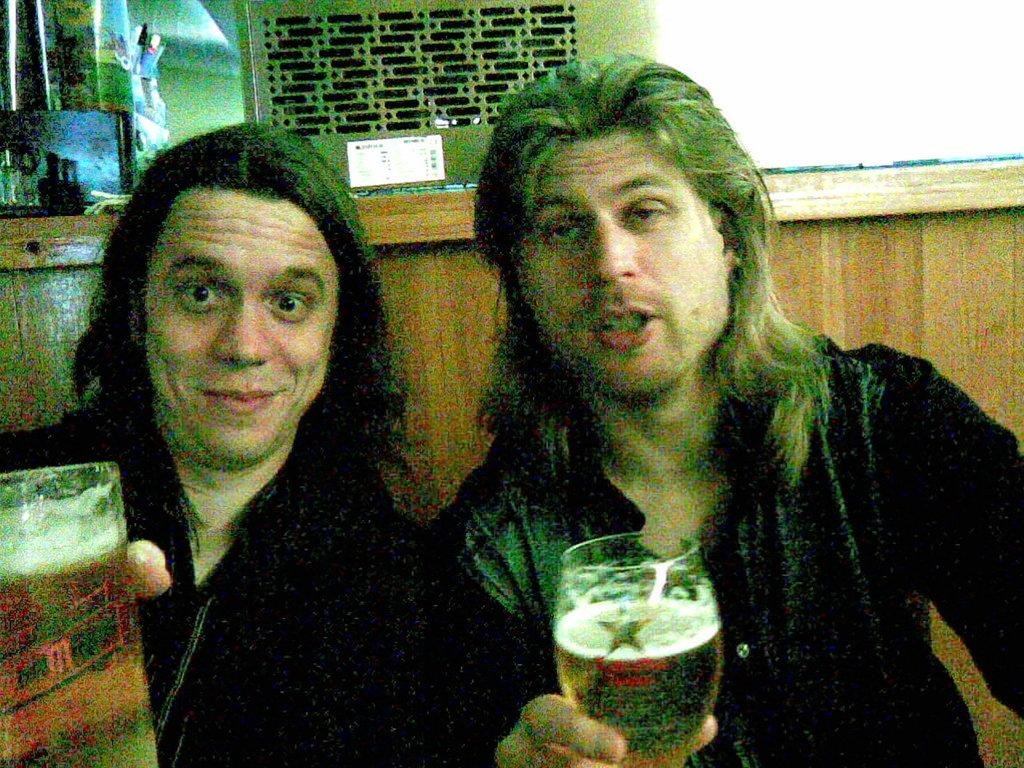How many people are in the image? There are two guys in the image. What are the guys holding in their hands? The guys are holding a glass of beer in their hands. What type of door can be seen in the image? There is no door present in the image; it only features two guys holding glasses of beer. 